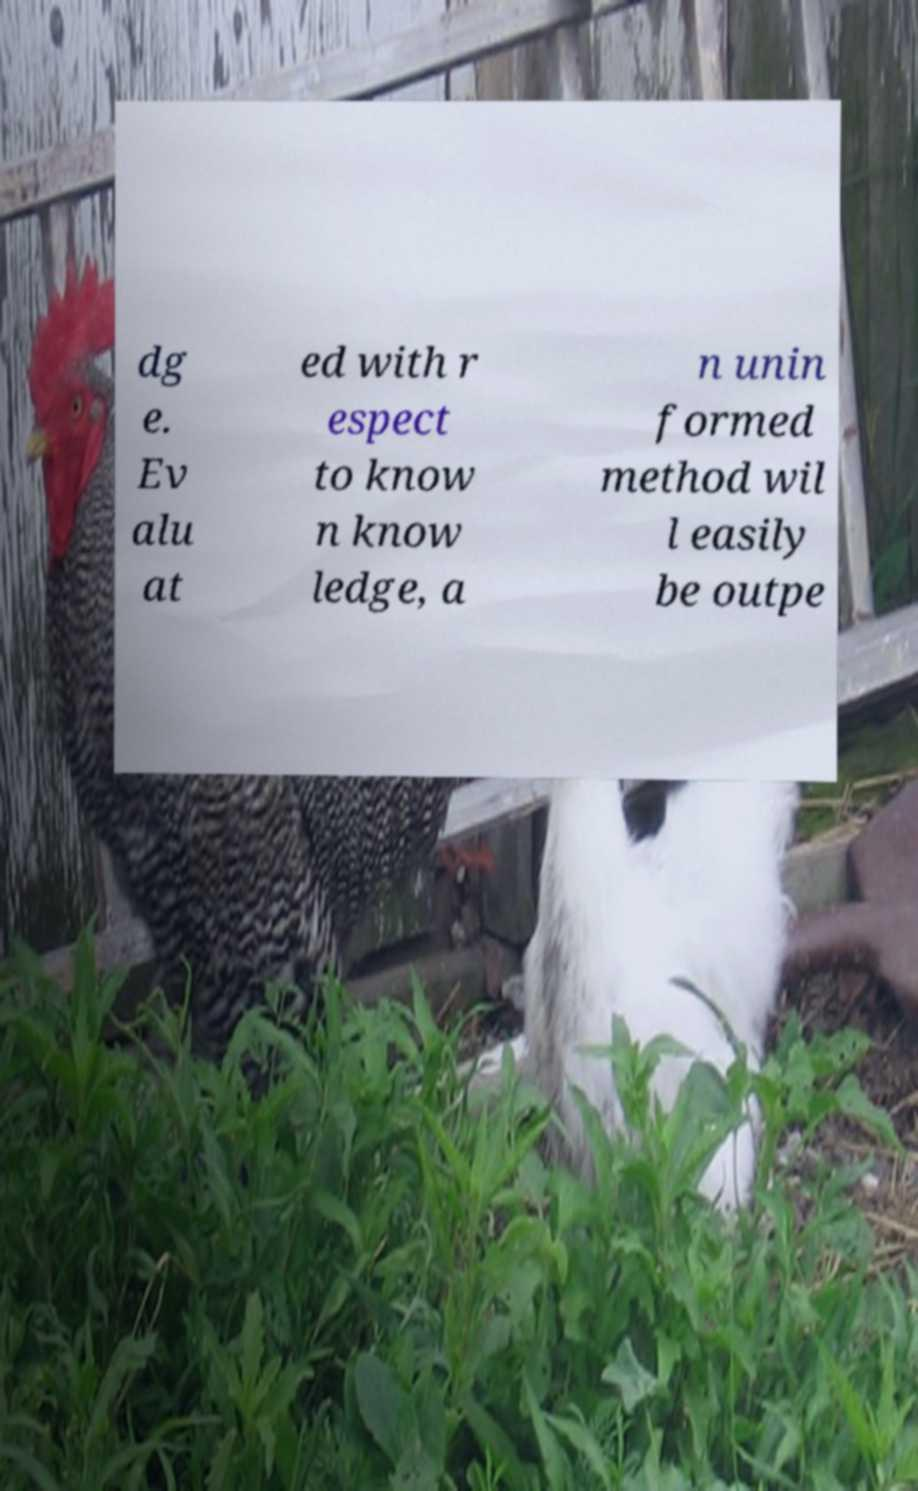For documentation purposes, I need the text within this image transcribed. Could you provide that? dg e. Ev alu at ed with r espect to know n know ledge, a n unin formed method wil l easily be outpe 